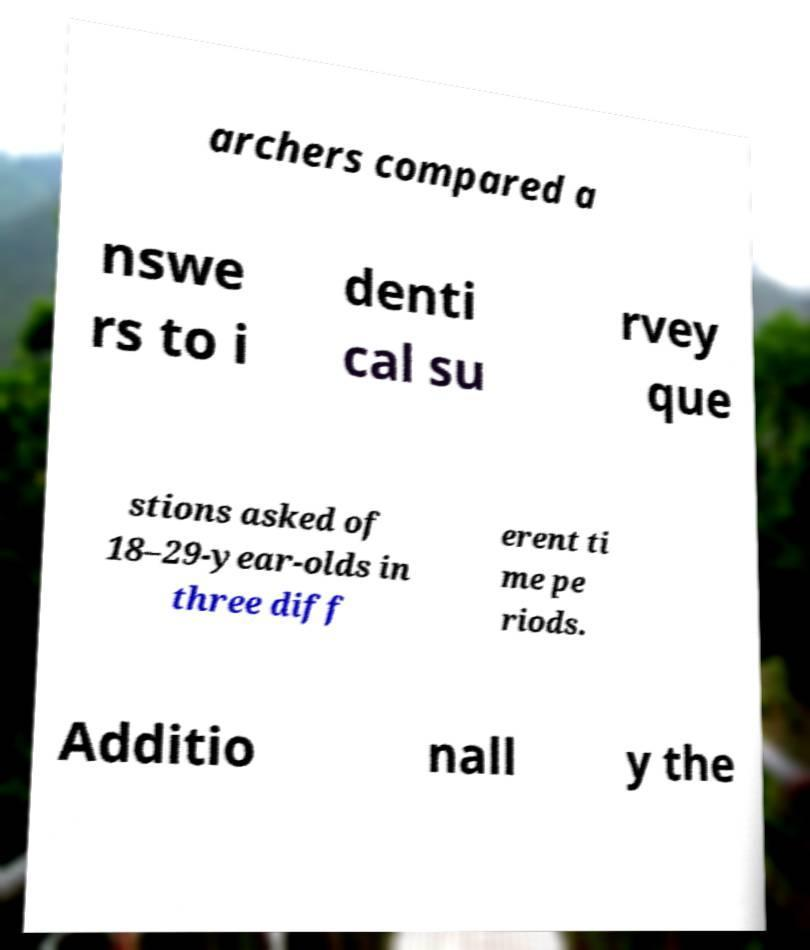Please read and relay the text visible in this image. What does it say? archers compared a nswe rs to i denti cal su rvey que stions asked of 18–29-year-olds in three diff erent ti me pe riods. Additio nall y the 